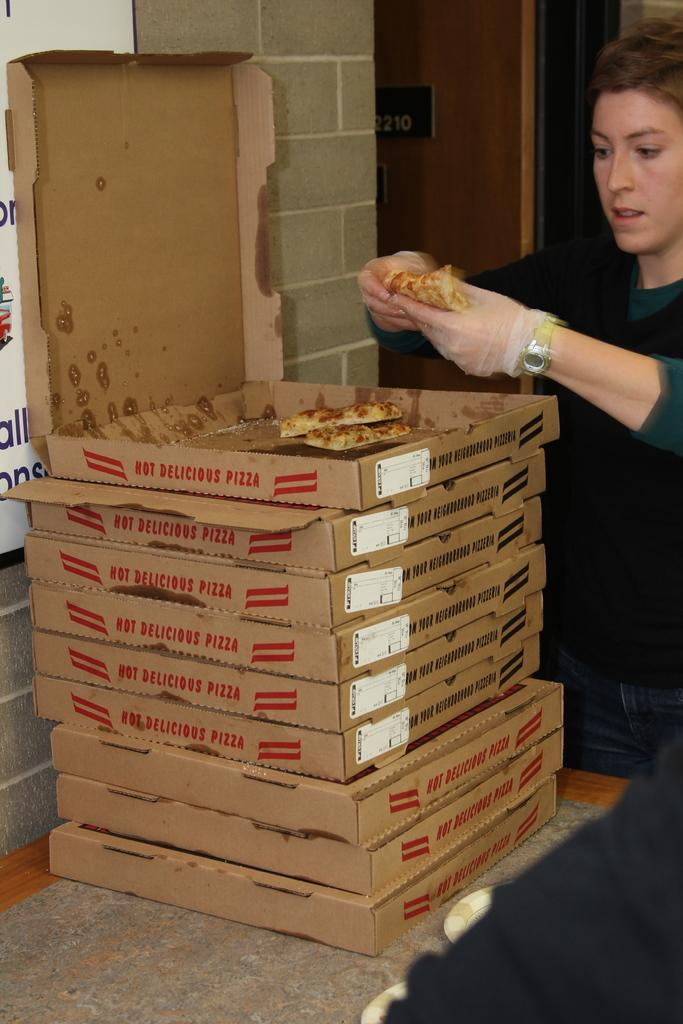<image>
Present a compact description of the photo's key features. a stack of pizzas that say 'hot delicious pizza' on the side of them 